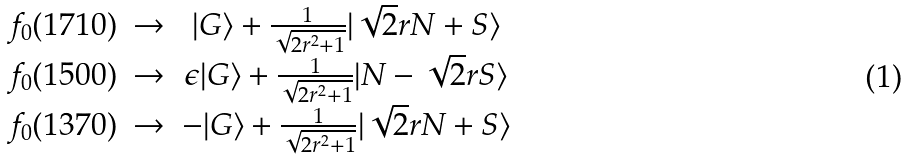<formula> <loc_0><loc_0><loc_500><loc_500>\begin{array} { c c c } f _ { 0 } ( 1 7 1 0 ) & \rightarrow & | G \rangle + \frac { 1 } { \sqrt { 2 r ^ { 2 } + 1 } } | \sqrt { 2 } r N + S \rangle \\ f _ { 0 } ( 1 5 0 0 ) & \rightarrow & \epsilon | G \rangle + \frac { 1 } { \sqrt { 2 r ^ { 2 } + 1 } } | N - \sqrt { 2 } r S \rangle \\ f _ { 0 } ( 1 3 7 0 ) & \rightarrow & - | G \rangle + \frac { 1 } { \sqrt { 2 r ^ { 2 } + 1 } } | \sqrt { 2 } r N + S \rangle \\ \end{array}</formula> 